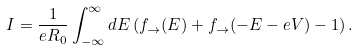Convert formula to latex. <formula><loc_0><loc_0><loc_500><loc_500>I = \frac { 1 } { e R _ { 0 } } \int _ { - \infty } ^ { \infty } d E \left ( f _ { \rightarrow } ( E ) + f _ { \rightarrow } ( - E - e V ) - 1 \right ) .</formula> 